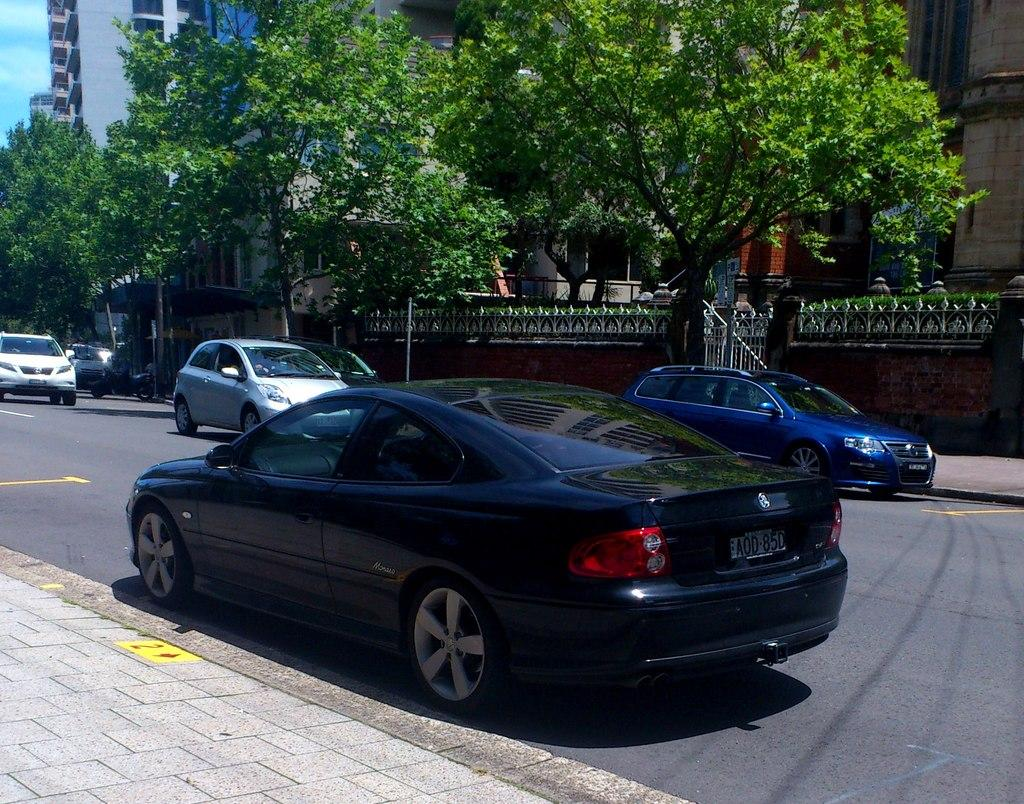What is the main feature of the image? There is a road in the image. What is happening on the road? There are cars on the road. What can be seen in the background of the image? There are trees, buildings, and the sky visible in the background of the image. What is the average income of the people buried in the cemetery in the image? There is no cemetery present in the image, so it is not possible to determine the average income of any people buried there. 